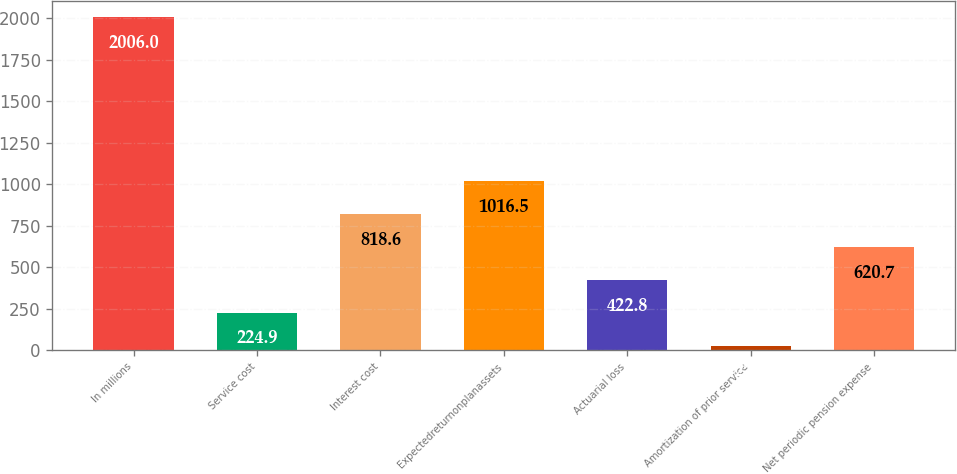Convert chart to OTSL. <chart><loc_0><loc_0><loc_500><loc_500><bar_chart><fcel>In millions<fcel>Service cost<fcel>Interest cost<fcel>Expectedreturnonplanassets<fcel>Actuarial loss<fcel>Amortization of prior service<fcel>Net periodic pension expense<nl><fcel>2006<fcel>224.9<fcel>818.6<fcel>1016.5<fcel>422.8<fcel>27<fcel>620.7<nl></chart> 